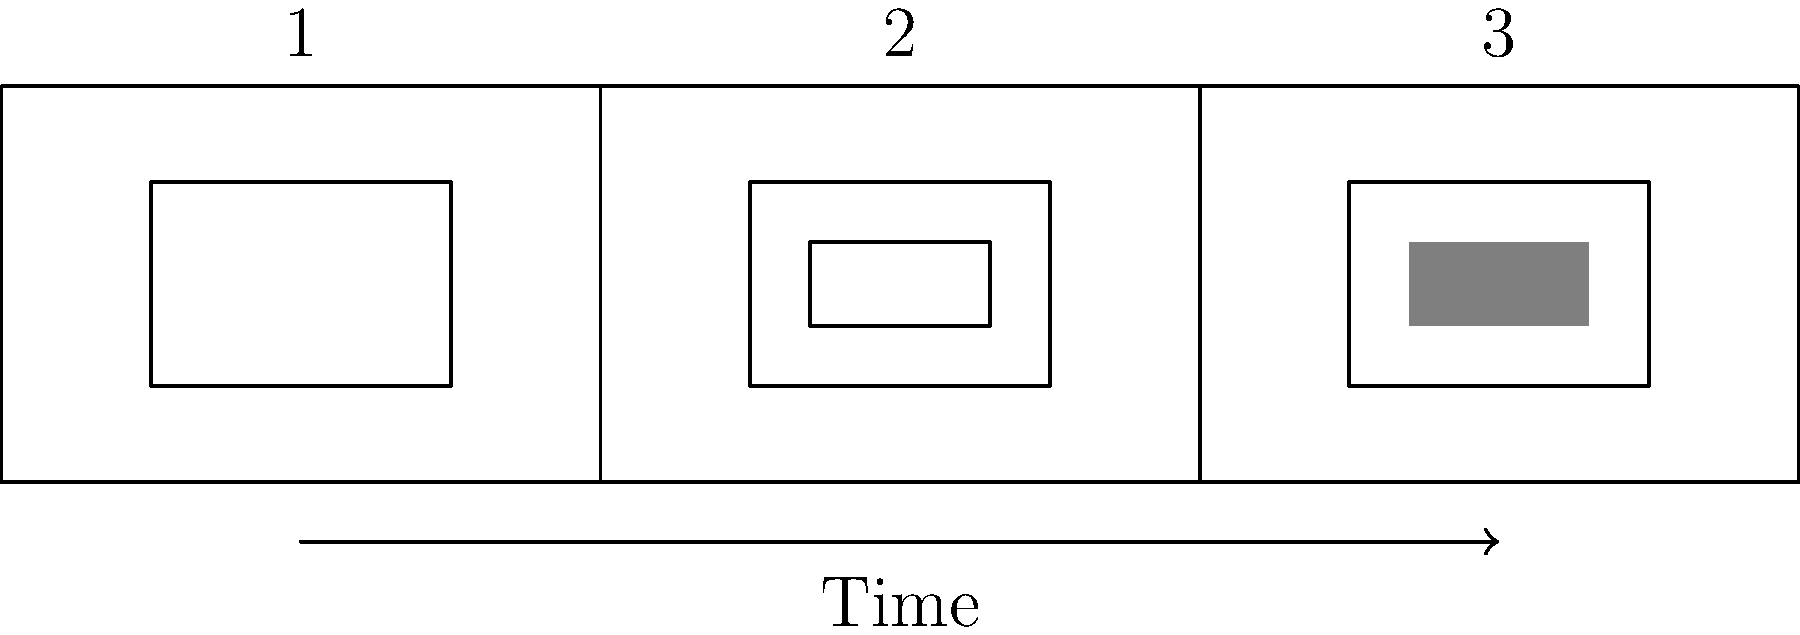In this storyboard sequence, which visual storytelling technique is being employed to create a sense of focus and emphasis as the frames progress? To identify the visual storytelling technique used in this storyboard sequence, let's analyze the progression of frames:

1. Frame 1: We see a basic rectangular shape within the frame, representing a simple composition.

2. Frame 2: The rectangular shape is still present, but now there's an additional smaller rectangle inside it. This suggests a narrowing of focus or a "zooming in" effect.

3. Frame 3: The same structure as Frame 2 is maintained, but now the innermost rectangle is filled with a solid color (gray in this case). This further emphasizes the central element of the composition.

This progression demonstrates the use of the "Hitchcock zoom" or "dolly zoom" technique, also known as the "vertigo effect." In filmmaking, this technique involves simultaneously zooming in with the camera lens while moving the camera backward (or vice versa). The result is that the subject remains the same size in the frame while the background appears to change.

In this storyboard representation, we see a similar effect achieved through the narrowing of focus and increasing emphasis on the central element. This technique is often used to create a sense of unease, to emphasize a particular object or character, or to symbolize a character's realization or epiphany.

As a filmmaker inspired by theatrical traditions, you might recognize this as a visual parallel to the way a spotlight narrows on stage to focus the audience's attention on a particular actor or scene element.
Answer: Dolly zoom (Hitchcock zoom) 